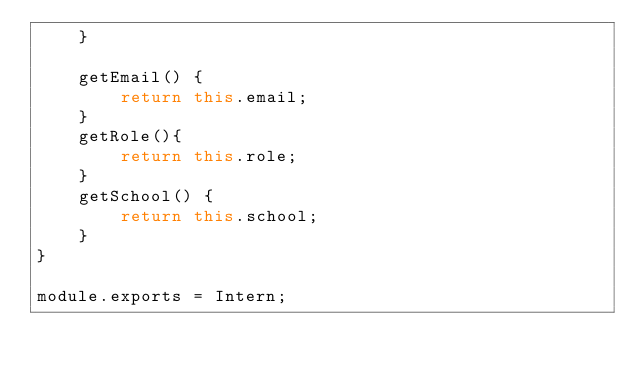Convert code to text. <code><loc_0><loc_0><loc_500><loc_500><_JavaScript_>    }
    
    getEmail() {
        return this.email;
    }
    getRole(){
        return this.role;
    }
    getSchool() {
        return this.school;
    }
}

module.exports = Intern;</code> 